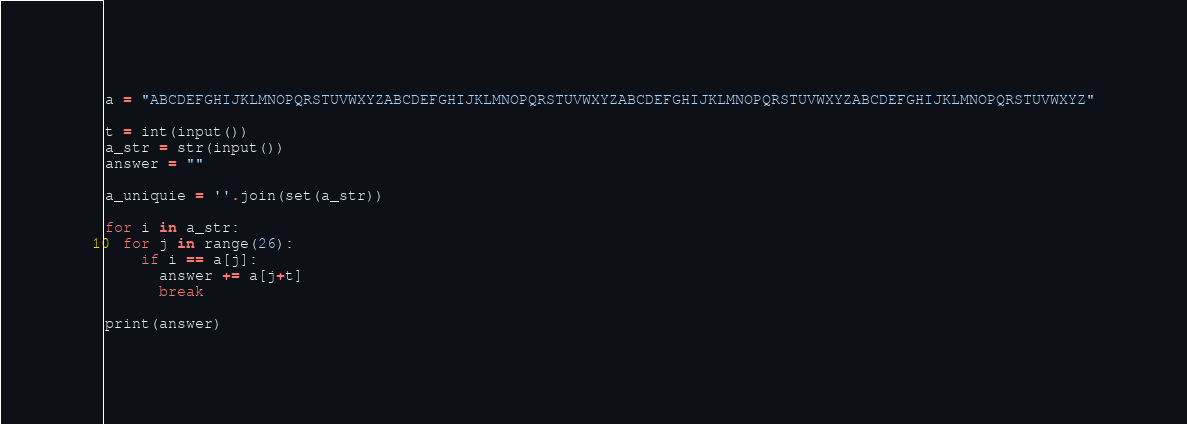Convert code to text. <code><loc_0><loc_0><loc_500><loc_500><_Python_>a = "ABCDEFGHIJKLMNOPQRSTUVWXYZABCDEFGHIJKLMNOPQRSTUVWXYZABCDEFGHIJKLMNOPQRSTUVWXYZABCDEFGHIJKLMNOPQRSTUVWXYZ"

t = int(input())
a_str = str(input())
answer = ""

a_uniquie = ''.join(set(a_str))

for i in a_str:
  for j in range(26):
    if i == a[j]:
      answer += a[j+t]
      break

print(answer)
</code> 